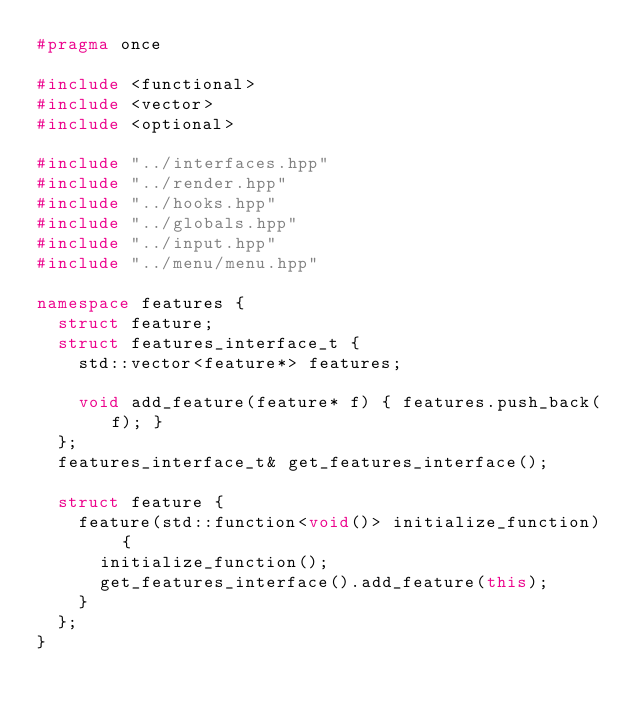Convert code to text. <code><loc_0><loc_0><loc_500><loc_500><_C++_>#pragma once

#include <functional>
#include <vector>
#include <optional>

#include "../interfaces.hpp"
#include "../render.hpp"
#include "../hooks.hpp"
#include "../globals.hpp"
#include "../input.hpp"
#include "../menu/menu.hpp"

namespace features {
	struct feature;
	struct features_interface_t {
		std::vector<feature*> features;

		void add_feature(feature* f) { features.push_back(f); }
	};
	features_interface_t& get_features_interface();

	struct feature {
		feature(std::function<void()> initialize_function) {
			initialize_function();
			get_features_interface().add_feature(this);
		}
	};
}</code> 